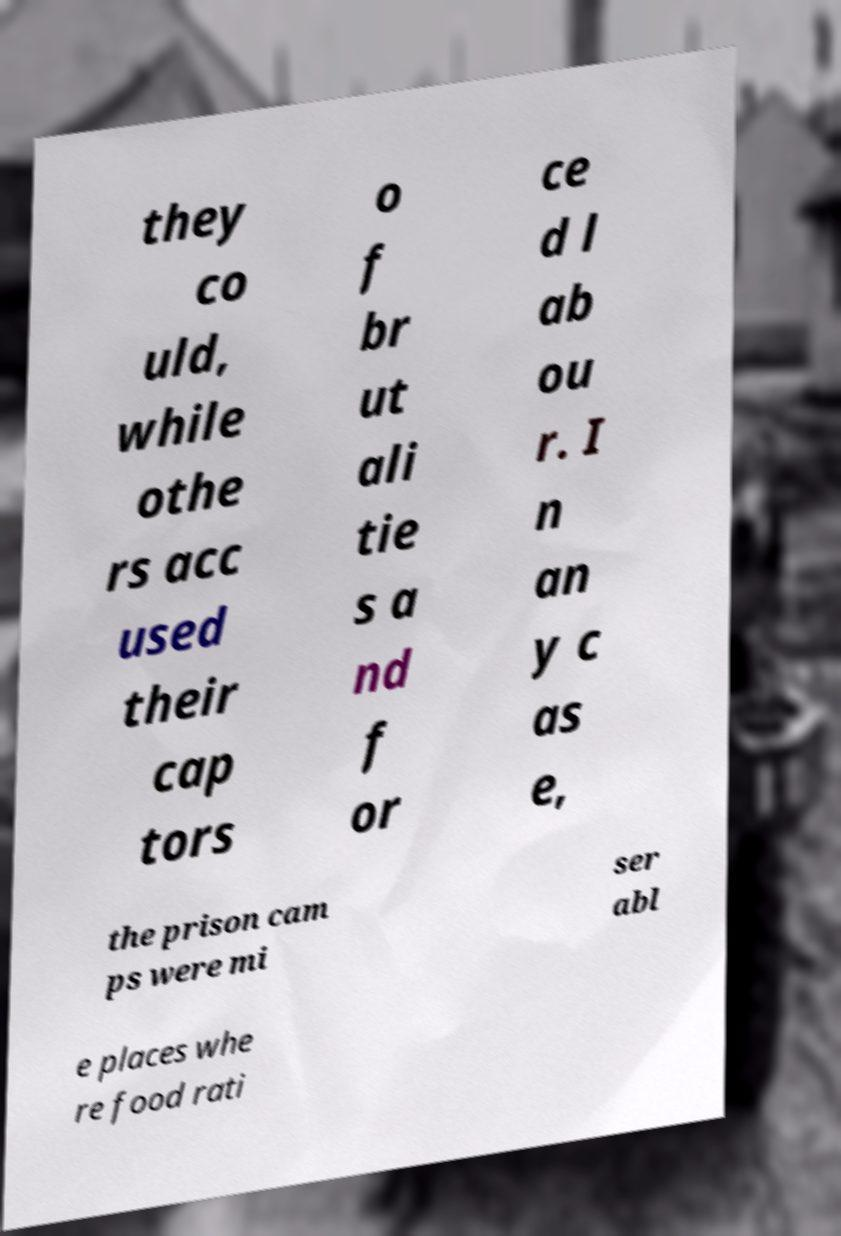Can you read and provide the text displayed in the image?This photo seems to have some interesting text. Can you extract and type it out for me? they co uld, while othe rs acc used their cap tors o f br ut ali tie s a nd f or ce d l ab ou r. I n an y c as e, the prison cam ps were mi ser abl e places whe re food rati 